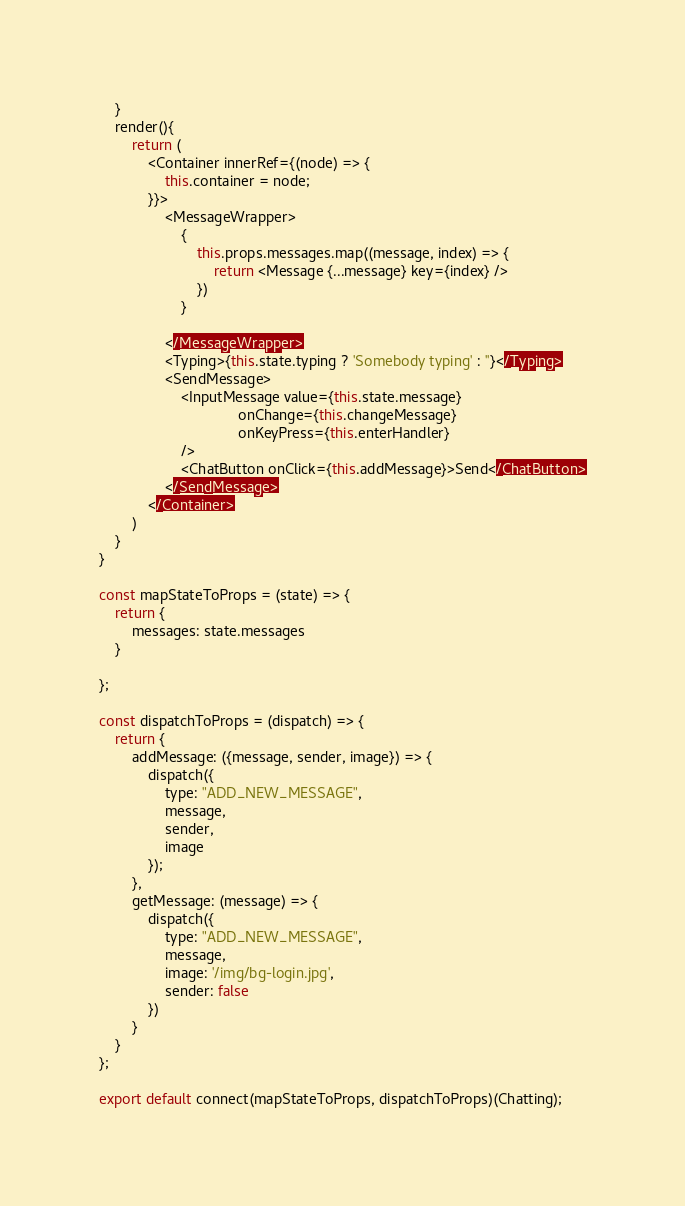<code> <loc_0><loc_0><loc_500><loc_500><_JavaScript_>

    }
    render(){
        return (
            <Container innerRef={(node) => {
                this.container = node;
            }}>
                <MessageWrapper>
                    {
                        this.props.messages.map((message, index) => {
                            return <Message {...message} key={index} />
                        })
                    }

                </MessageWrapper>
                <Typing>{this.state.typing ? 'Somebody typing' : ''}</Typing>
                <SendMessage>
                    <InputMessage value={this.state.message}
                                  onChange={this.changeMessage}
                                  onKeyPress={this.enterHandler}
                    />
                    <ChatButton onClick={this.addMessage}>Send</ChatButton>
                </SendMessage>
            </Container>
        )
    }
}

const mapStateToProps = (state) => {
    return {
        messages: state.messages
    }

};

const dispatchToProps = (dispatch) => {
    return {
        addMessage: ({message, sender, image}) => {
            dispatch({
                type: "ADD_NEW_MESSAGE",
                message,
                sender,
                image
            });
        },
        getMessage: (message) => {
            dispatch({
                type: "ADD_NEW_MESSAGE",
                message,
                image: '/img/bg-login.jpg',
                sender: false
            })
        }
    }
};

export default connect(mapStateToProps, dispatchToProps)(Chatting);</code> 